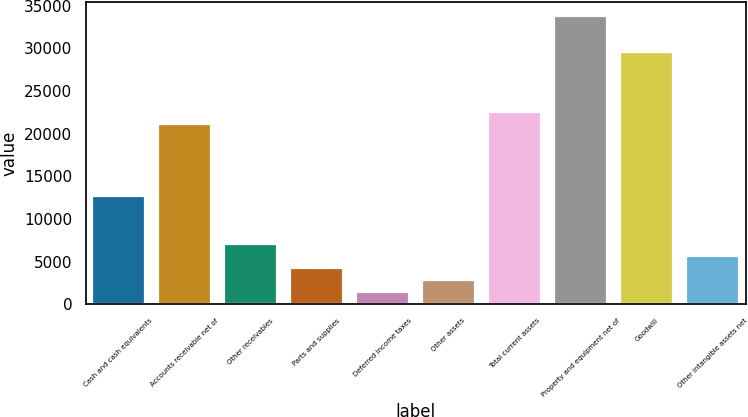Convert chart. <chart><loc_0><loc_0><loc_500><loc_500><bar_chart><fcel>Cash and cash equivalents<fcel>Accounts receivable net of<fcel>Other receivables<fcel>Parts and supplies<fcel>Deferred income taxes<fcel>Other assets<fcel>Total current assets<fcel>Property and equipment net of<fcel>Goodwill<fcel>Other intangible assets net<nl><fcel>12666.3<fcel>21106.5<fcel>7039.5<fcel>4226.1<fcel>1412.7<fcel>2819.4<fcel>22513.2<fcel>33766.8<fcel>29546.7<fcel>5632.8<nl></chart> 